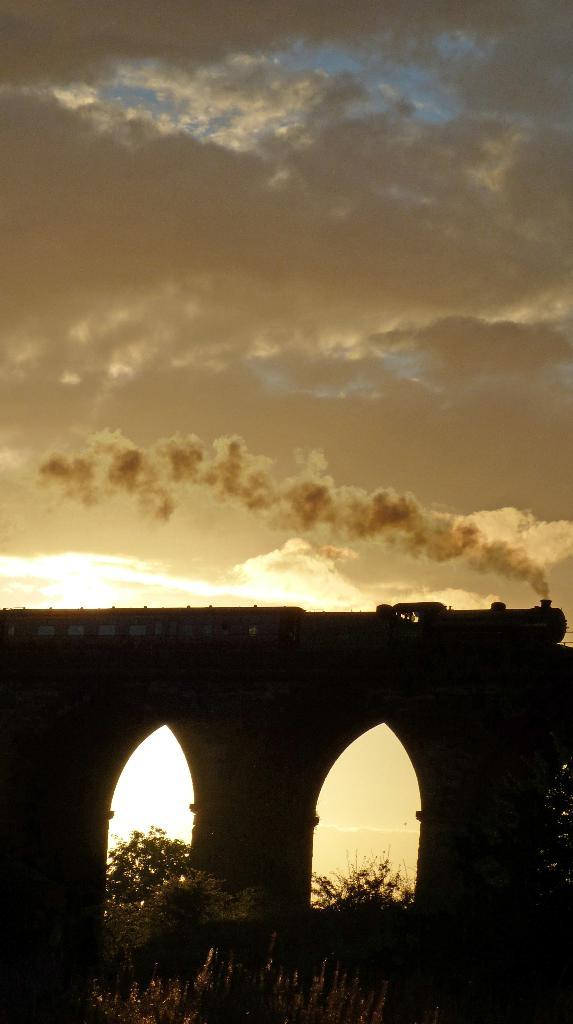What is the main subject of the image? The main subject of the image is a train on a bridge. Can you describe the bridge in the image? The bridge has pillars supporting it. What type of vegetation can be seen in the image? There are many trees in the image. How would you describe the sky in the image? The sky is cloudy in the image. What type of marble is being used to decorate the train in the image? There is no marble present in the image, as the train is not shown to be decorated with any marble. 